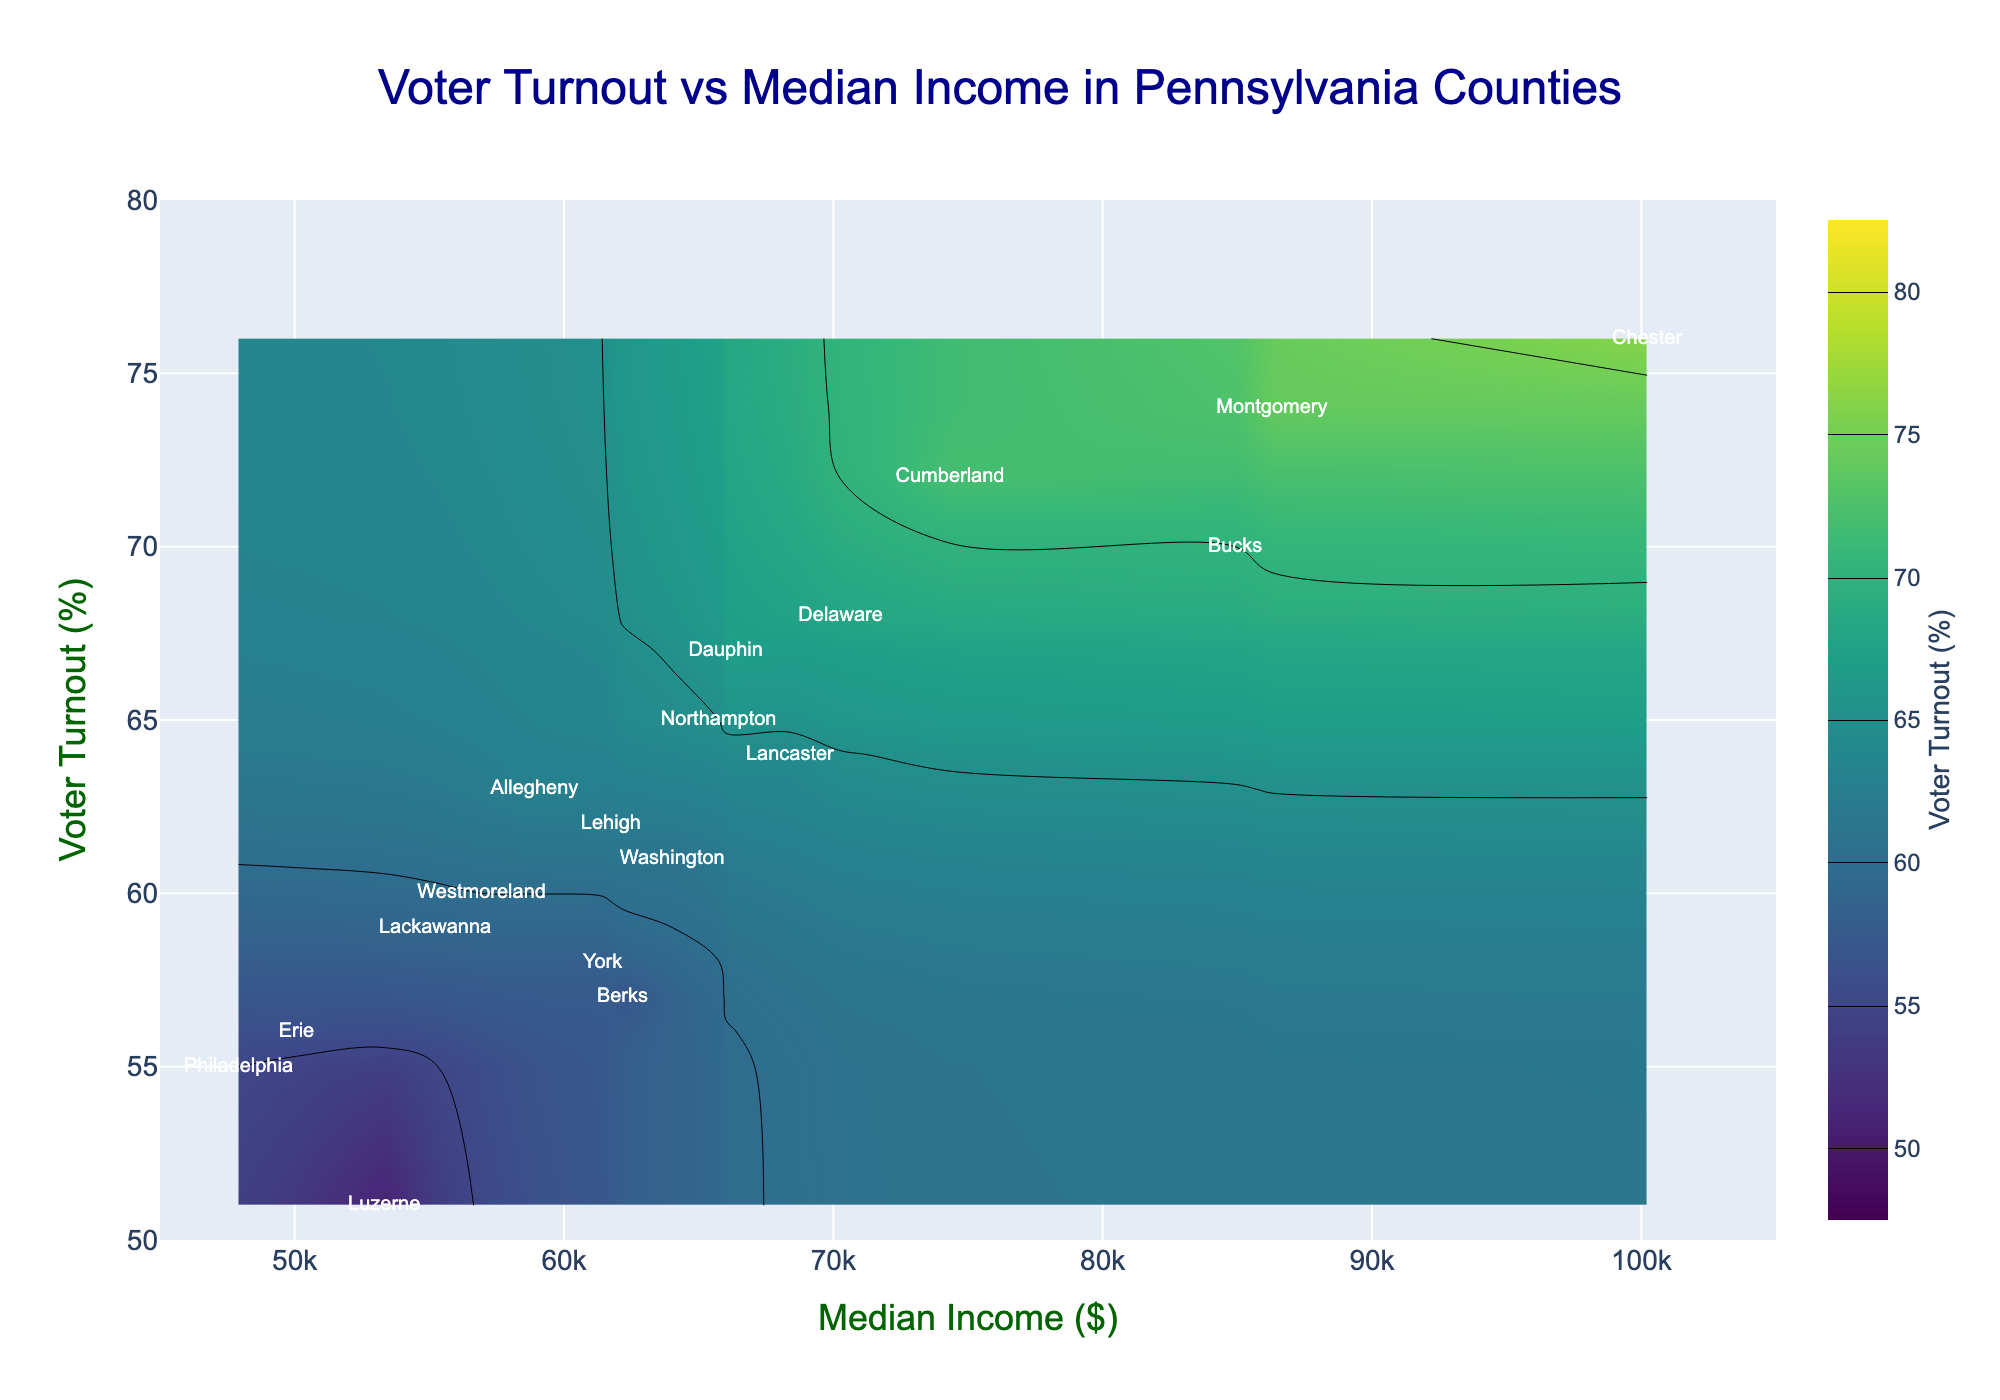What's the title of the figure? The title is located at the top of the figure. It provides a summary of what the figure represents. By looking at the plot, we see the title text.
Answer: Voter Turnout vs Median Income in Pennsylvania Counties What is the range of the x-axis? The x-axis represents the 'Median Income ($)'. By examining the visual range of the x-axis, the minimum value is the leftmost tick and the maximum is the rightmost tick.
Answer: 45000 to 105000 Which county has the highest median income? The highest median income can be identified by finding the data point farthest to the right on the x-axis. Chester county is located at the highest value on the x-axis.
Answer: Chester What is the voter turnout percentage for Chester County? Locate Chester county on the plot and read the corresponding y-axis value. The plot shows that Chester has a 76% voter turnout, with confirmation through hover information.
Answer: 76% What is the median income for Philadelphia? Find Philadelphia on the plot and read the corresponding x-axis value. The hover information shows Philadelphia's median income.
Answer: 47915 Which county has the lowest voter turnout, and what is that turnout? The lowest voter turnout is the lowest point on the y-axis. Luzerne county is at the lowest point with a 51% voter turnout, confirmed by hover information.
Answer: Luzerne, 51% How many counties have a voter turnout greater than 70%? Examine the points on the plot above the 70% mark on the y-axis. Identify all such counties and count them. There are three counties: Montgomery, Chester, and Cumberland.
Answer: 3 Do higher median incomes generally correlate with higher voter turnout? To determine correlation, observe the general direction of data points on the plot. Data points tend to rise from left to right, indicating a positive correlation.
Answer: Yes Which county has the closest voter turnout to the average voter turnout of all counties? Calculate the average voter turnout of all counties, which is (55+63+74+70+68+64+76+58+57+60+62+51+65+67+56+72+59+61) / 18 = 63%. Compare this average to individual counties to find the closest value. Allegheny has a 63% turnout.
Answer: Allegheny What is the difference in median income between the highest and lowest median income counties? Identify the highest median income (Chester, 100214) and the lowest median income (Philadelphia, 47915). Subtract the lowest from the highest: 100214 - 47915.
Answer: 52299 